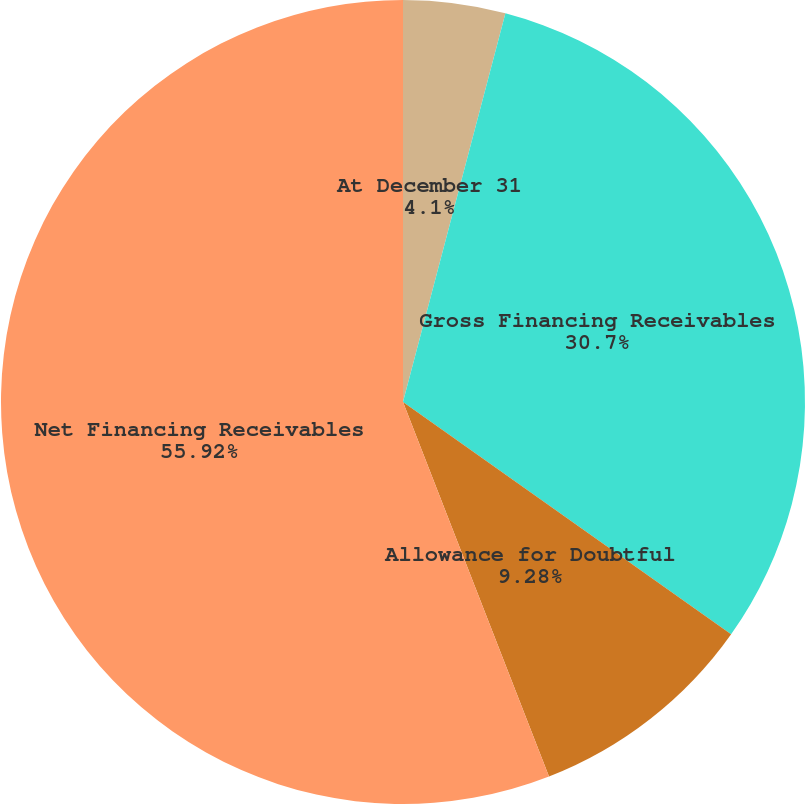Convert chart. <chart><loc_0><loc_0><loc_500><loc_500><pie_chart><fcel>At December 31<fcel>Gross Financing Receivables<fcel>Allowance for Doubtful<fcel>Net Financing Receivables<nl><fcel>4.1%<fcel>30.7%<fcel>9.28%<fcel>55.91%<nl></chart> 